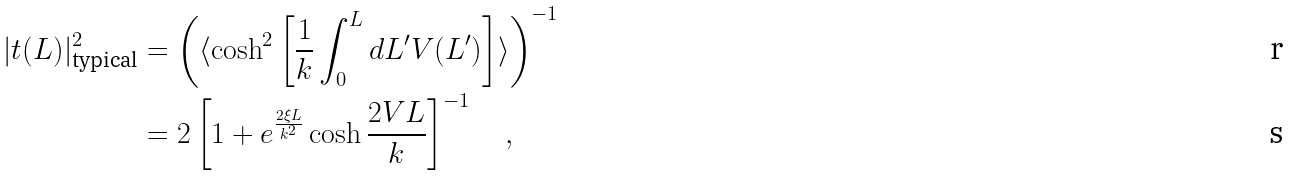Convert formula to latex. <formula><loc_0><loc_0><loc_500><loc_500>| t ( L ) | ^ { 2 } _ { \text {typical} } & = \left ( \langle \cosh ^ { 2 } \left [ \frac { 1 } { k } \int ^ { L } _ { 0 } d L ^ { \prime } V ( L ^ { \prime } ) \right ] \rangle \right ) ^ { - 1 } \\ & = 2 \left [ 1 + e ^ { \frac { 2 \xi L } { k ^ { 2 } } } \cosh \frac { 2 V L } { k } \right ] ^ { - 1 } \quad ,</formula> 